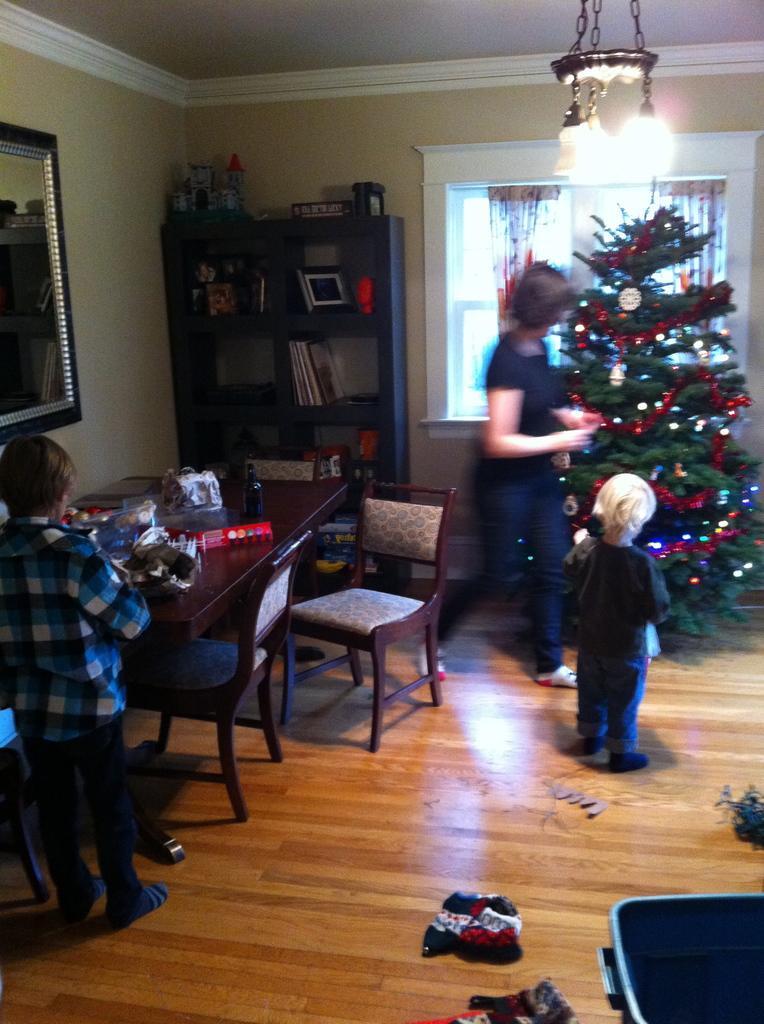In one or two sentences, can you explain what this image depicts? The image is inside of room in the image there are three people. On right side there are two people woman and a kid standing in front of a christmas tree. On left side there is a boy standing in front of a table, on table we can see some toys,bottle and a hand bag and we can also see two chairs and a shelf. On shelf there are some books,photo frames,toys. In middle there is a window which is closed and curtains we can also see a wall on wall a mirror is attached to it. On top there is a roof and lights. 